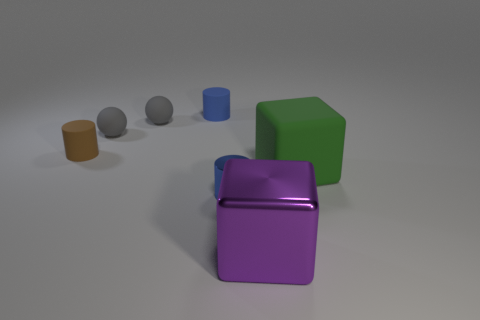Add 1 brown cylinders. How many objects exist? 8 Subtract all balls. How many objects are left? 5 Add 1 purple shiny blocks. How many purple shiny blocks are left? 2 Add 3 small gray spheres. How many small gray spheres exist? 5 Subtract 0 green balls. How many objects are left? 7 Subtract all purple metallic balls. Subtract all gray matte spheres. How many objects are left? 5 